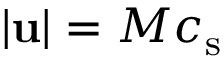Convert formula to latex. <formula><loc_0><loc_0><loc_500><loc_500>| u | = M { c _ { s } }</formula> 